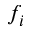<formula> <loc_0><loc_0><loc_500><loc_500>f _ { i }</formula> 